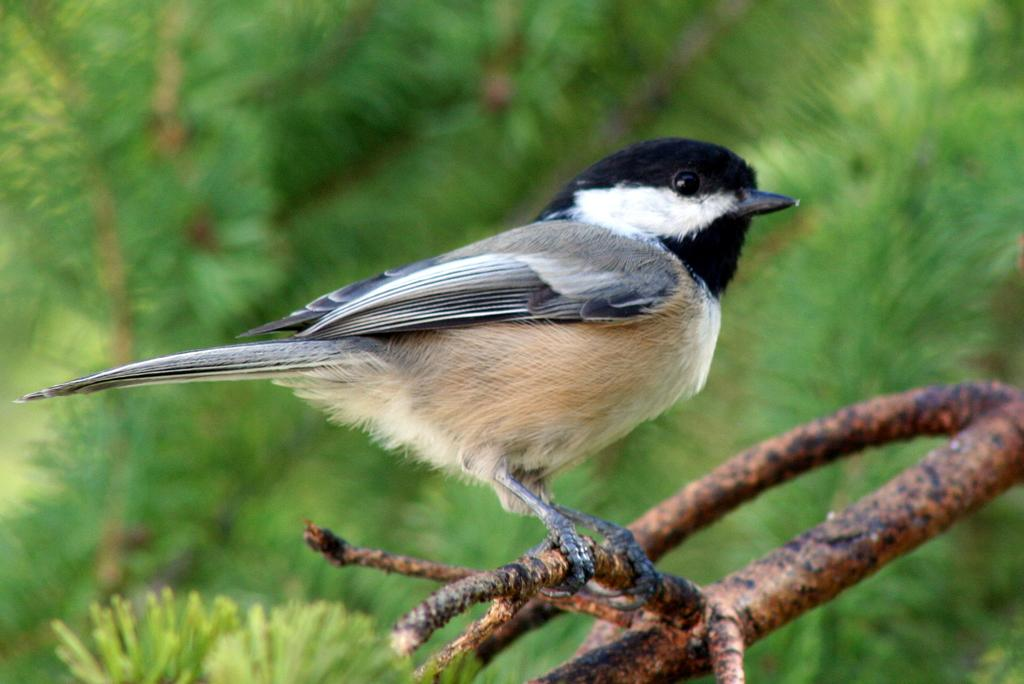What type of animal can be seen in the image? There is a bird in the image. Where is the bird located? The bird is on a branch. What can be seen in the background of the image? There are trees in the background of the image. How would you describe the background of the image? The background is blurry. What type of cake is being served at the knowledge conference in the image? There is no cake or knowledge conference present in the image; it features a bird on a branch with a blurry background. 